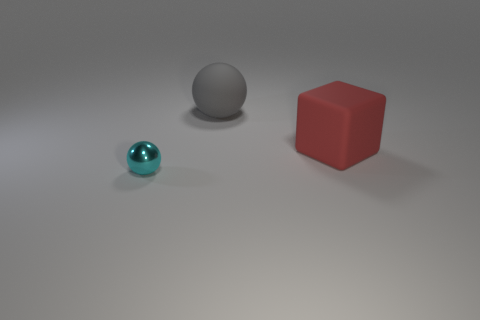Add 3 red rubber cylinders. How many objects exist? 6 Subtract all cubes. How many objects are left? 2 Subtract 0 yellow blocks. How many objects are left? 3 Subtract all cyan rubber cylinders. Subtract all gray rubber spheres. How many objects are left? 2 Add 3 tiny shiny things. How many tiny shiny things are left? 4 Add 1 small red shiny cylinders. How many small red shiny cylinders exist? 1 